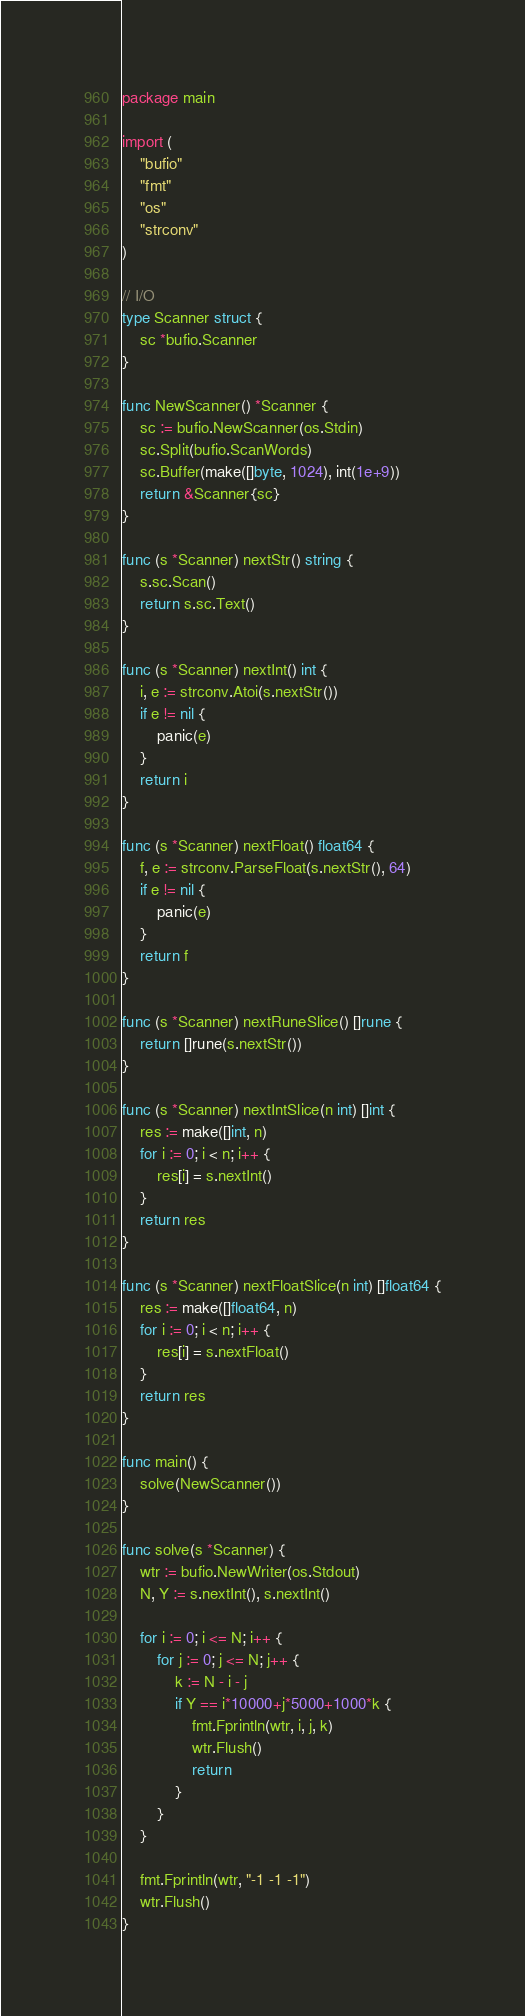Convert code to text. <code><loc_0><loc_0><loc_500><loc_500><_Go_>package main

import (
	"bufio"
	"fmt"
	"os"
	"strconv"
)

// I/O
type Scanner struct {
	sc *bufio.Scanner
}

func NewScanner() *Scanner {
	sc := bufio.NewScanner(os.Stdin)
	sc.Split(bufio.ScanWords)
	sc.Buffer(make([]byte, 1024), int(1e+9))
	return &Scanner{sc}
}

func (s *Scanner) nextStr() string {
	s.sc.Scan()
	return s.sc.Text()
}

func (s *Scanner) nextInt() int {
	i, e := strconv.Atoi(s.nextStr())
	if e != nil {
		panic(e)
	}
	return i
}

func (s *Scanner) nextFloat() float64 {
	f, e := strconv.ParseFloat(s.nextStr(), 64)
	if e != nil {
		panic(e)
	}
	return f
}

func (s *Scanner) nextRuneSlice() []rune {
	return []rune(s.nextStr())
}

func (s *Scanner) nextIntSlice(n int) []int {
	res := make([]int, n)
	for i := 0; i < n; i++ {
		res[i] = s.nextInt()
	}
	return res
}

func (s *Scanner) nextFloatSlice(n int) []float64 {
	res := make([]float64, n)
	for i := 0; i < n; i++ {
		res[i] = s.nextFloat()
	}
	return res
}

func main() {
	solve(NewScanner())
}

func solve(s *Scanner) {
	wtr := bufio.NewWriter(os.Stdout)
	N, Y := s.nextInt(), s.nextInt()

	for i := 0; i <= N; i++ {
		for j := 0; j <= N; j++ {
			k := N - i - j
			if Y == i*10000+j*5000+1000*k {
				fmt.Fprintln(wtr, i, j, k)
				wtr.Flush()
				return
			}
		}
	}

	fmt.Fprintln(wtr, "-1 -1 -1")
	wtr.Flush()
}
</code> 